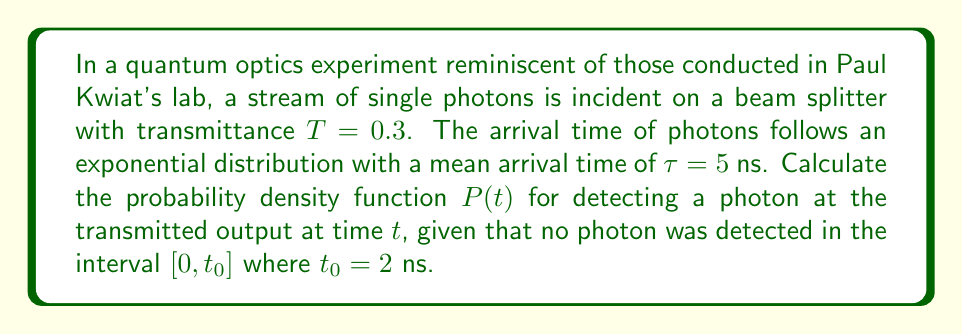Can you answer this question? Let's approach this step-by-step:

1) The exponential distribution for photon arrivals is given by:
   $$f(t) = \frac{1}{\tau} e^{-t/\tau}$$

2) The probability of transmission through the beam splitter is $T = 0.3$.

3) The probability of no detection in the interval $[0,t_0]$ is:
   $$P(\text{no detection}) = \exp\left(-\int_0^{t_0} T f(t) dt\right)$$

4) Evaluating this integral:
   $$\begin{align}
   P(\text{no detection}) &= \exp\left(-T\int_0^{t_0} \frac{1}{\tau} e^{-t/\tau} dt\right) \\
   &= \exp\left(-T \left[-e^{-t/\tau}\right]_0^{t_0}\right) \\
   &= \exp\left(-T \left(1 - e^{-t_0/\tau}\right)\right) \\
   &= \exp\left(-0.3 \left(1 - e^{-2/5}\right)\right)
   \end{align}$$

5) The probability density function $P(t)$ for detecting a photon at time $t$, given no detection before $t_0$, is:
   $$P(t) = \frac{T f(t)}{P(\text{no detection})} \quad \text{for } t > t_0$$

6) Substituting all values:
   $$P(t) = \frac{0.3 \cdot \frac{1}{5} e^{-t/5}}{\exp\left(-0.3 \left(1 - e^{-2/5}\right)\right)} \quad \text{for } t > 2$$

7) Simplifying:
   $$P(t) = 0.06 \cdot \exp\left(0.3 \left(1 - e^{-2/5}\right) - \frac{t}{5}\right) \quad \text{for } t > 2$$
Answer: $P(t) = 0.06 \cdot \exp\left(0.3 \left(1 - e^{-2/5}\right) - \frac{t}{5}\right)$ for $t > 2$ ns 